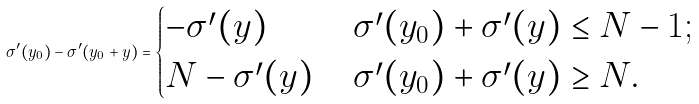Convert formula to latex. <formula><loc_0><loc_0><loc_500><loc_500>\sigma ^ { \prime } ( y _ { 0 } ) - \sigma ^ { \prime } ( y _ { 0 } + y ) = \begin{cases} - \sigma ^ { \prime } ( y ) & \, \sigma ^ { \prime } ( y _ { 0 } ) + \sigma ^ { \prime } ( y ) \leq N - 1 ; \\ N - \sigma ^ { \prime } ( y ) & \, \sigma ^ { \prime } ( y _ { 0 } ) + \sigma ^ { \prime } ( y ) \geq N . \end{cases}</formula> 